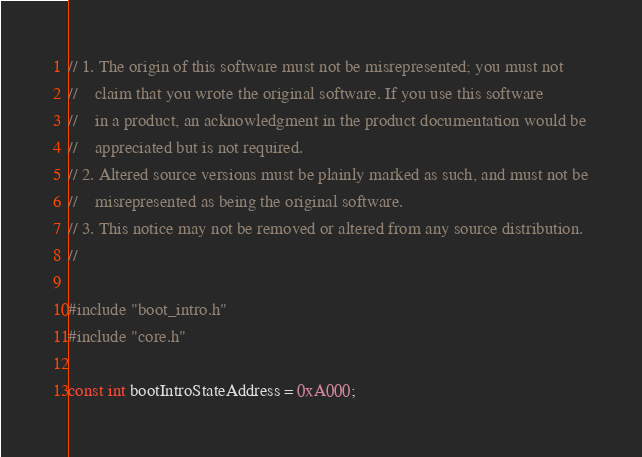Convert code to text. <code><loc_0><loc_0><loc_500><loc_500><_C_>// 1. The origin of this software must not be misrepresented; you must not
//    claim that you wrote the original software. If you use this software
//    in a product, an acknowledgment in the product documentation would be
//    appreciated but is not required.
// 2. Altered source versions must be plainly marked as such, and must not be
//    misrepresented as being the original software.
// 3. This notice may not be removed or altered from any source distribution.
//

#include "boot_intro.h"
#include "core.h"

const int bootIntroStateAddress = 0xA000;
</code> 